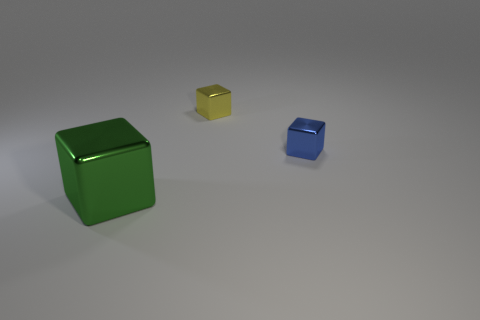How large would you say the green cube is compared to the other objects? The green cube appears to be the largest object among the cubes displayed, significantly larger than both the yellow and blue cubes. 